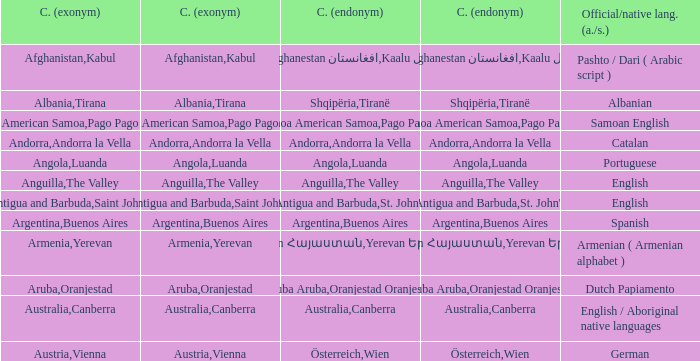How many capital cities does Australia have? 1.0. 